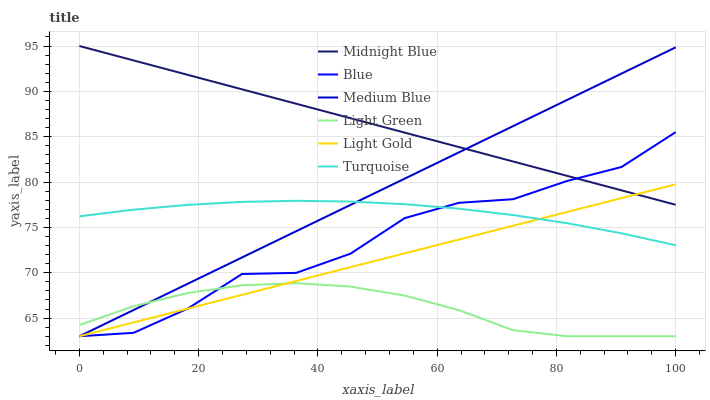Does Light Green have the minimum area under the curve?
Answer yes or no. Yes. Does Midnight Blue have the maximum area under the curve?
Answer yes or no. Yes. Does Turquoise have the minimum area under the curve?
Answer yes or no. No. Does Turquoise have the maximum area under the curve?
Answer yes or no. No. Is Midnight Blue the smoothest?
Answer yes or no. Yes. Is Blue the roughest?
Answer yes or no. Yes. Is Turquoise the smoothest?
Answer yes or no. No. Is Turquoise the roughest?
Answer yes or no. No. Does Blue have the lowest value?
Answer yes or no. Yes. Does Turquoise have the lowest value?
Answer yes or no. No. Does Midnight Blue have the highest value?
Answer yes or no. Yes. Does Turquoise have the highest value?
Answer yes or no. No. Is Light Green less than Turquoise?
Answer yes or no. Yes. Is Turquoise greater than Light Green?
Answer yes or no. Yes. Does Light Gold intersect Midnight Blue?
Answer yes or no. Yes. Is Light Gold less than Midnight Blue?
Answer yes or no. No. Is Light Gold greater than Midnight Blue?
Answer yes or no. No. Does Light Green intersect Turquoise?
Answer yes or no. No. 